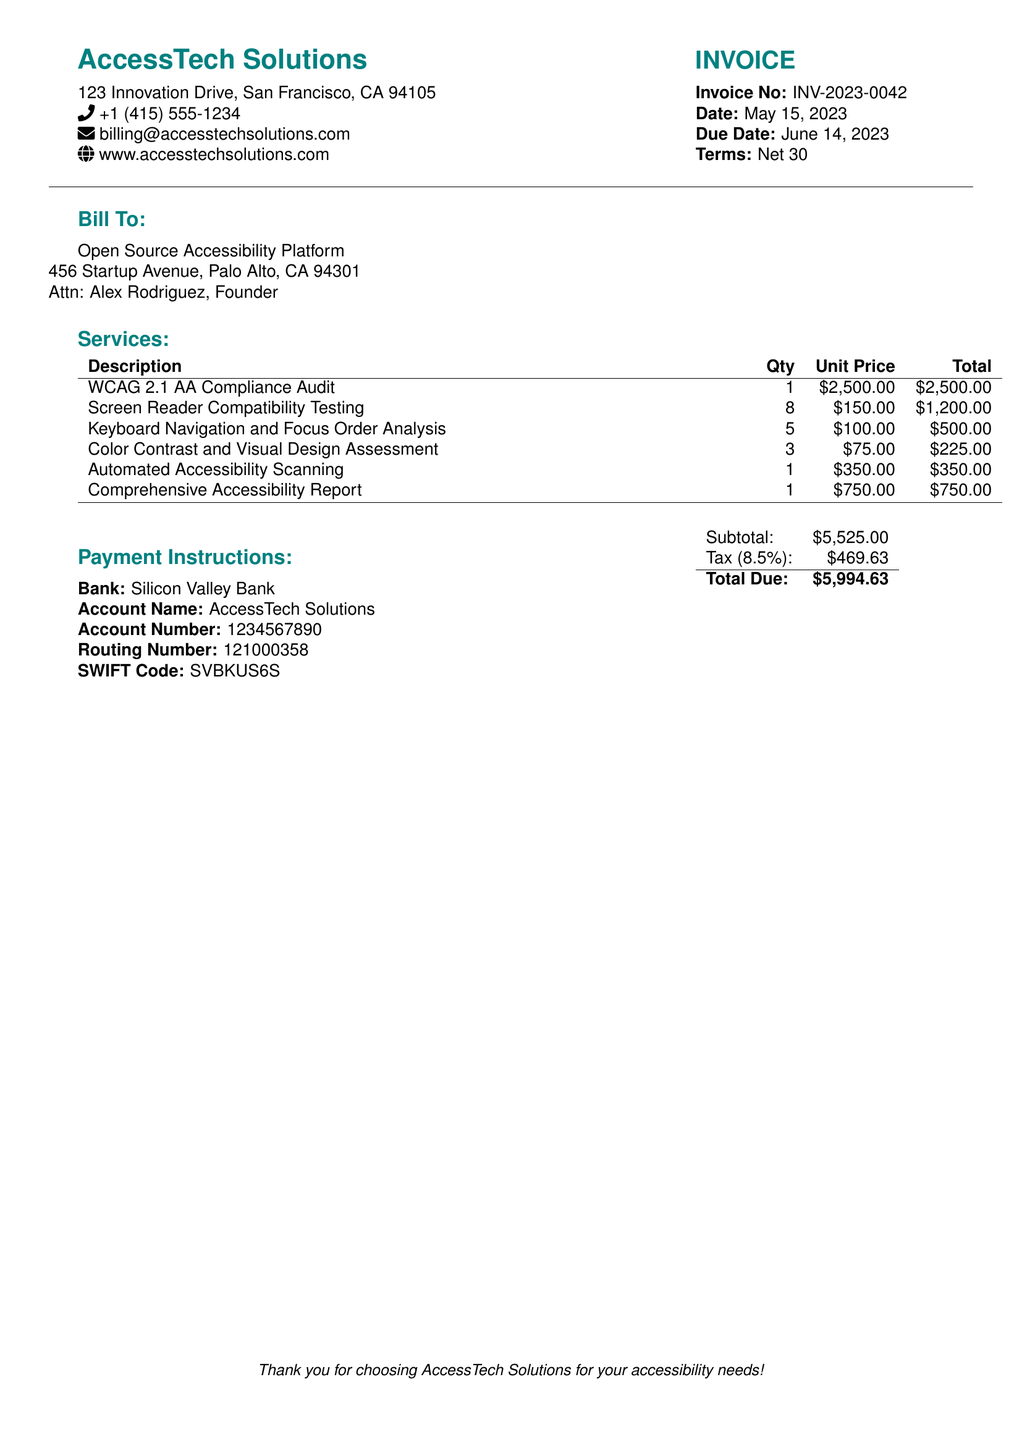What is the invoice number? The invoice number can be found in the document under the details section, labeled as "Invoice No".
Answer: INV-2023-0042 What is the due date for the payment? The due date is specifically listed under the invoice terms.
Answer: June 14, 2023 Who is the billing contact person? The billing contact person's name is provided in the "Bill To" section under "Attn".
Answer: Alex Rodriguez What is the total amount due? The total due is calculated from the subtotal and tax mentioned at the bottom of the invoice.
Answer: $5,994.63 How much was charged for the WCAG 2.1 AA Compliance Audit? The charge for this specific service is detailed in the "Services" section.
Answer: $2,500.00 What is the quantity of Screen Reader Compatibility Testing performed? The quantity for this service is listed in the table under "Qty" in the "Services" section.
Answer: 8 How much is the tax applied to the invoice? The tax amount is explicitly stated in the summary section at the end of the invoice.
Answer: $469.63 What is the account name for payment? The account name for payment is provided under the "Payment Instructions" section.
Answer: AccessTech Solutions What type of services were included in this invoice? The types of services provided can be found in the "Services" section of the document.
Answer: Accessibility Testing Services 